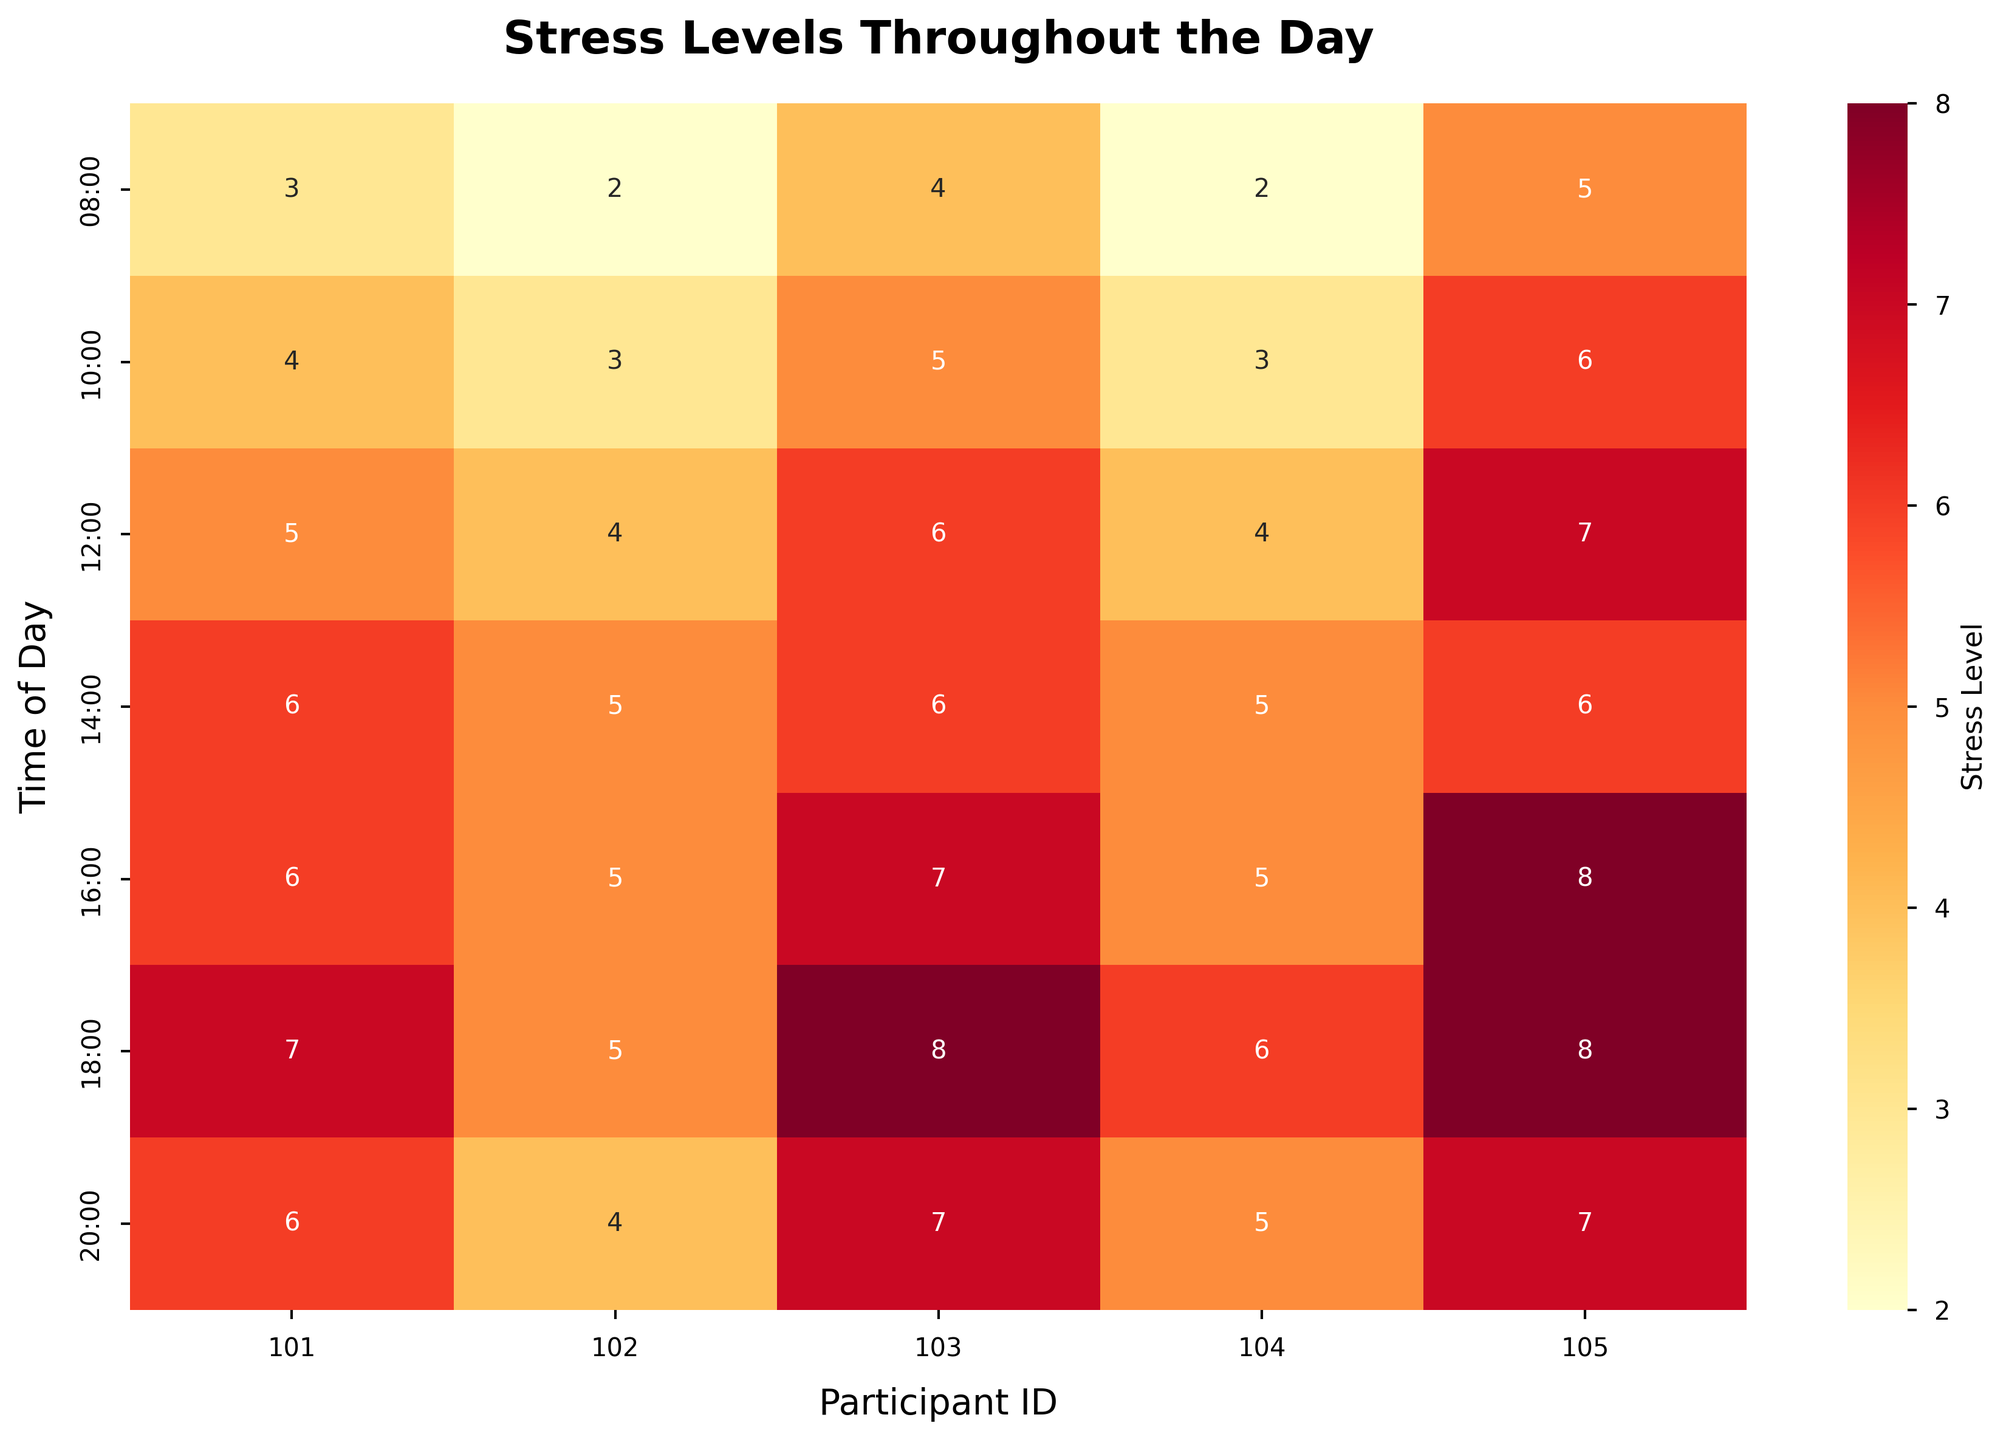**Question**: What is the title of the figure? **Explanation**: Look for the text at the top of the figure which is typically larger and bolder than other text.
Answer: **Answer**: Stress Levels Throughout the Day **Question**: At what time of day does participant 105 experience the highest stress level? **Explanation**: Find the row for participant 105 and locate the maximum value along the time of day. The highest stress level is 8 at both 16:00 and 18:00.
Answer: **Answer**: 16:00 and 18:00 **Question**: Which participant has the lowest stress level at 12:00? **Explanation**: Look at the values in the row for 12:00 and compare them. The lowest value is 4 for participants 102 and 104.
Answer: **Answer**: 102 and 104 **Question**: How does the stress level of participant 101 change from 08:00 to 12:00? **Explanation**: Follow the stress levels for participant 101 across the times 08:00, 10:00, and 12:00: 3, 4, and 5. The stress level increases progressively.
Answer: **Answer**: It increases **Question**: Which time of day shows the highest average stress level across all participants? **Explanation**: Calculate the average stress levels for each time of day by summing the stress levels for all participants and dividing by the number of participants. The averages are as follows: 
08:00: (3+2+4+2+5)/5 = 3.2 
10:00: (4+3+5+3+6)/5 = 4.2 
12:00: (5+4+6+4+7)/5 = 5.2 
14:00: (6+5+6+5+6)/5 = 5.6 
16:00: (6+5+7+5+8)/5 = 6.2 
18:00: (7+5+8+6+8)/5 = 6.8 
20:00: (6+4+7+5+7)/5 = 5.8 
The highest is 6.8 at 18:00.
Answer: **Answer**: 18:00 **Question**: At which time of day is the stress level of participant 103 equal to 6? **Explanation**: Look for the instances where participant 103 has a stress level of 6. This occurs at 12:00, 14:00, and 16:00.
Answer: **Answer**: 12:00, 14:00, and 16:00 **Question**: Which participant shows the least variation in stress levels throughout the day? **Explanation**: Compare the range (difference between highest and lowest values) of stress levels for each participant. Participant 102 shows the least variation as the stress levels are 2, 3, 4, 5, 5, 6, 7 giving a range of 4.
Answer: **Answer**: Participant 102 **Question**: How does the overall trend of stress levels progress throughout the day for all participants? **Explanation**: Observe the pattern in stress levels from morning (08:00) to night (20:00). Generally, stress levels tend to increase as time progresses, peaking around 18:00, then slightly decreasing at 20:00.
Answer: **Answer**: The stress levels generally increase throughout the day, peaking at 18:00 and then decreasing slightly at 20:00 **Question**: Which time of day has the most uniform stress levels across all participants? **Explanation**: Check for the time with the most similar stress levels across participants, i.e., the smallest range within a row. At 14:00 and 20:00, the stress levels range from 5-6 and 4-7 respectively, indicating a narrow range,  so 14:00 is more uniform.
Answer: **Answer**: 14:00 